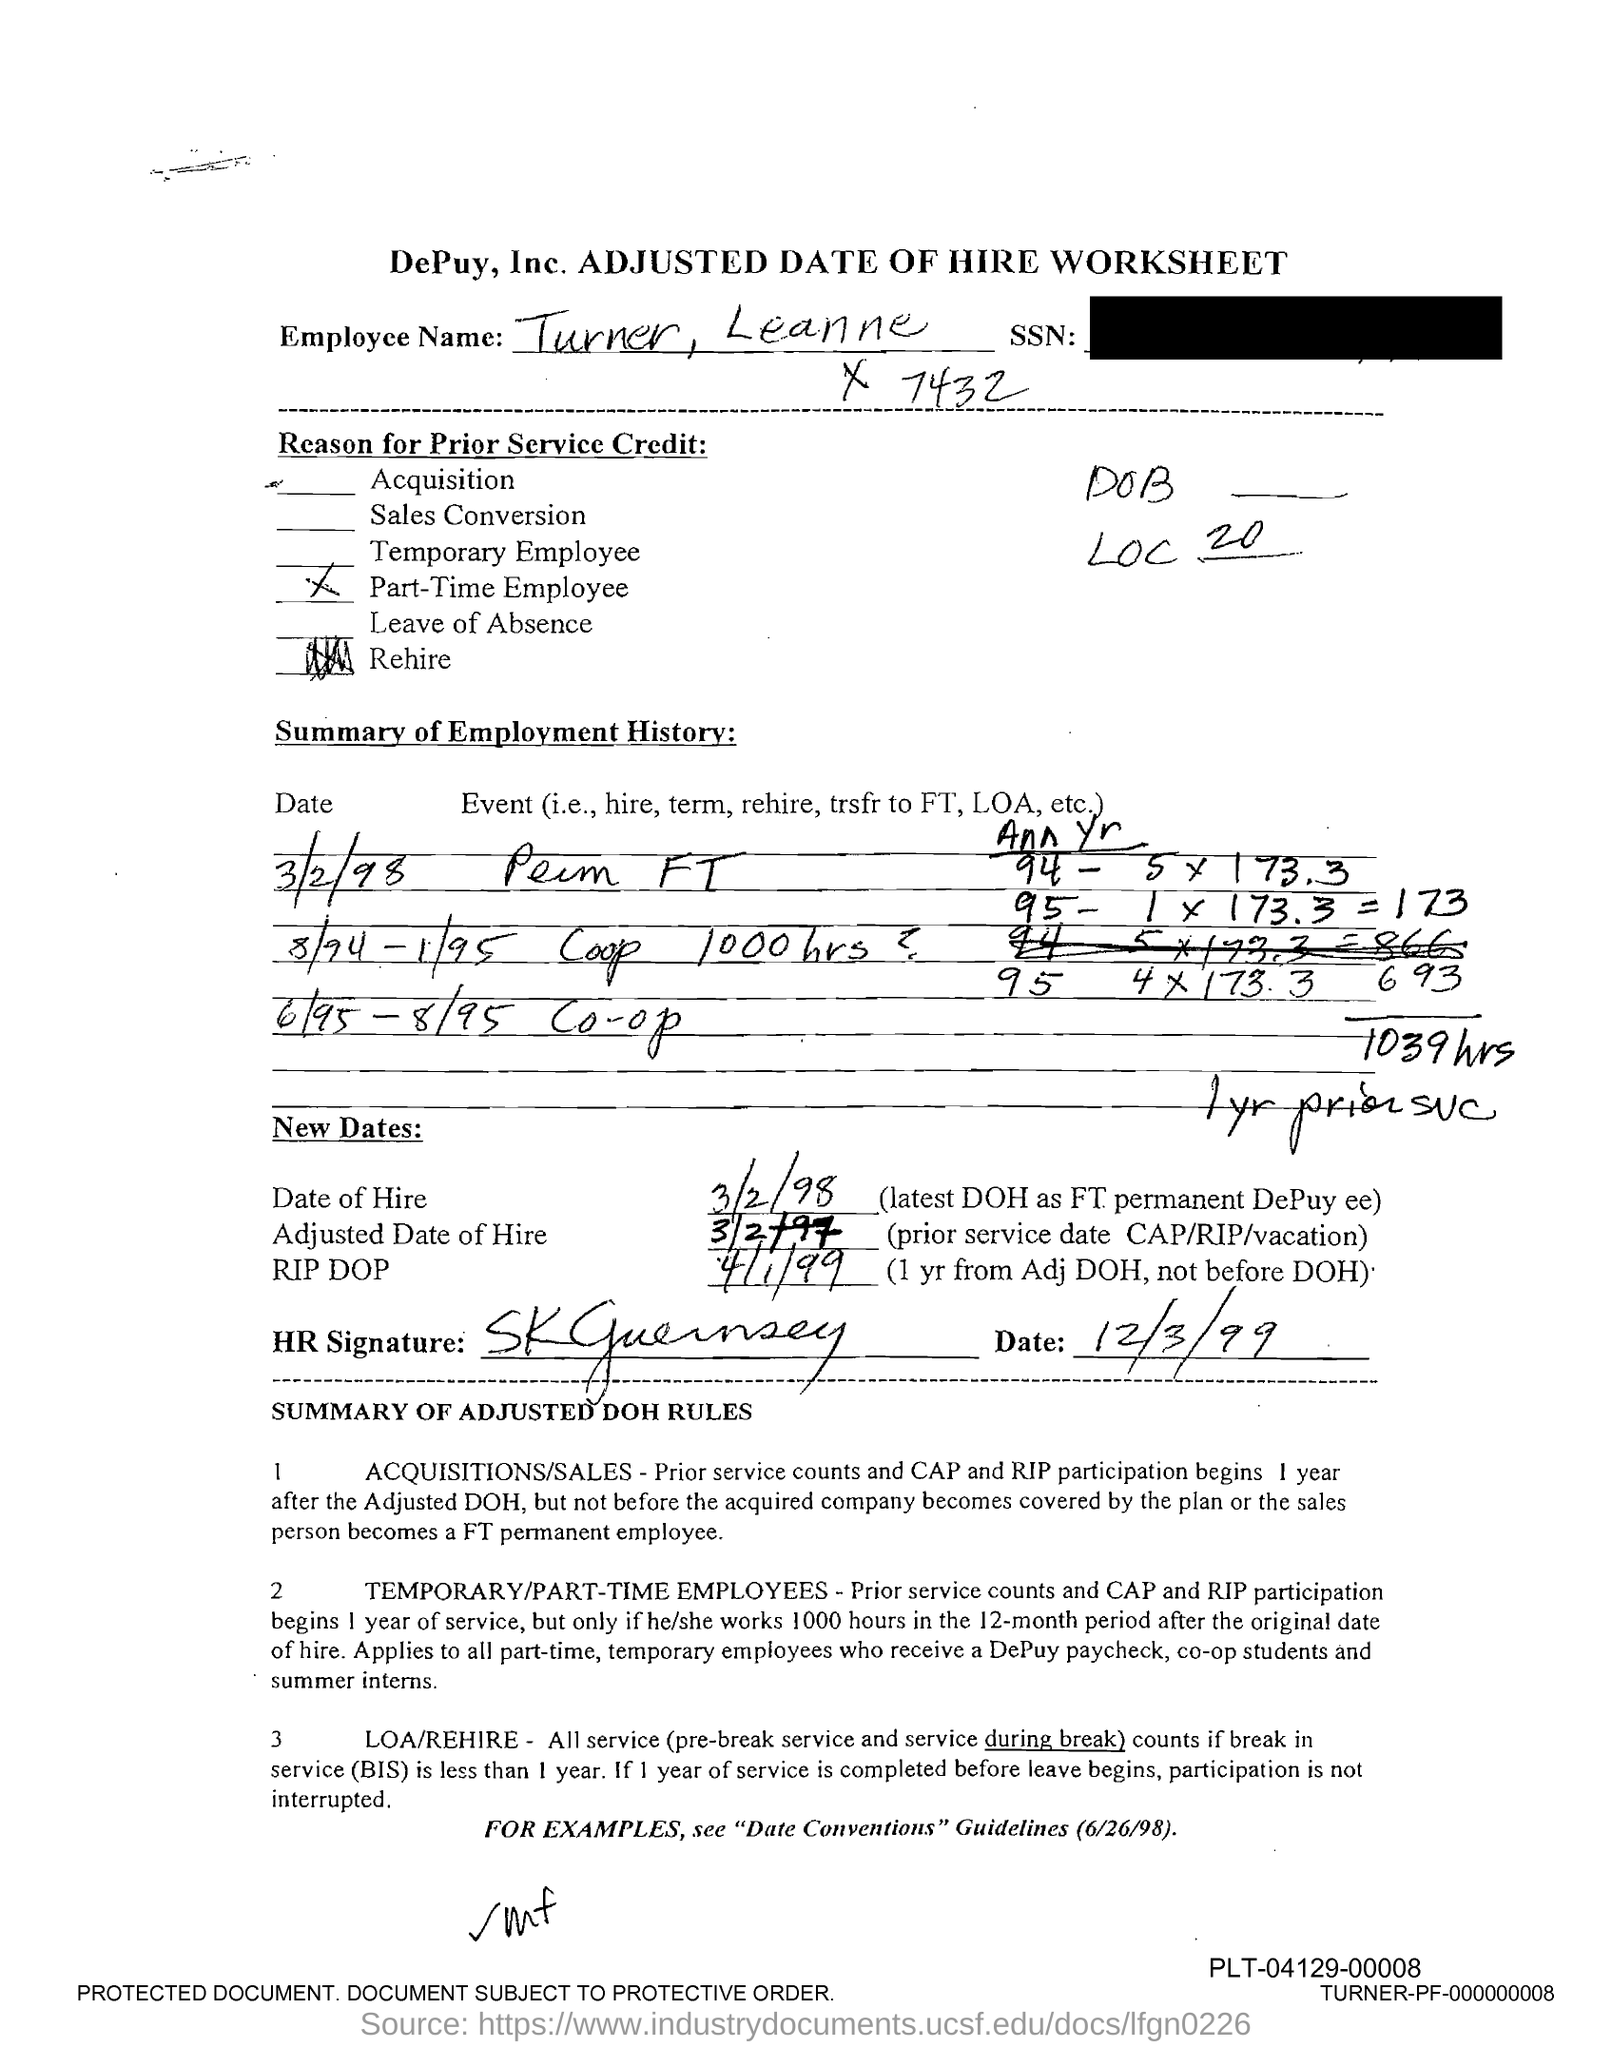What is the date of hire?
Keep it short and to the point. 3/2/98. What is the adjusted date of hire?
Give a very brief answer. 3/2/97. 